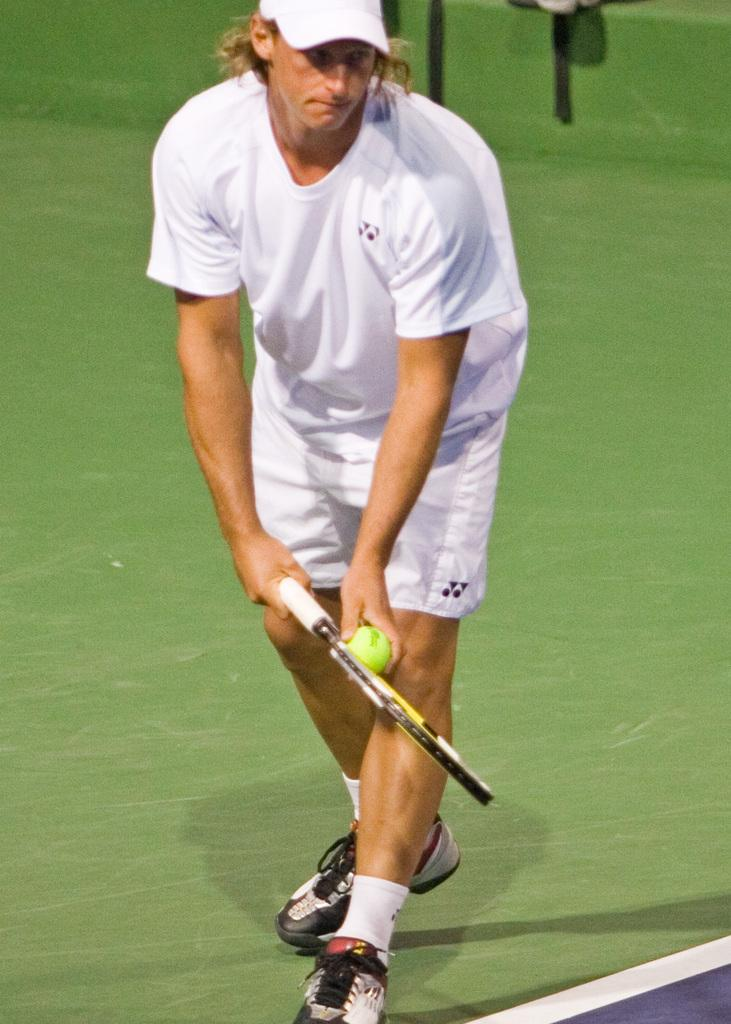What is the main subject of the picture? The main subject of the picture is a man. What is the man holding in the picture? The man is holding a tennis racket and a tennis ball. What type of flag is the man discussing with his friend in the image? There is no friend or discussion about a flag in the image; the man is holding a tennis racket and a tennis ball. 